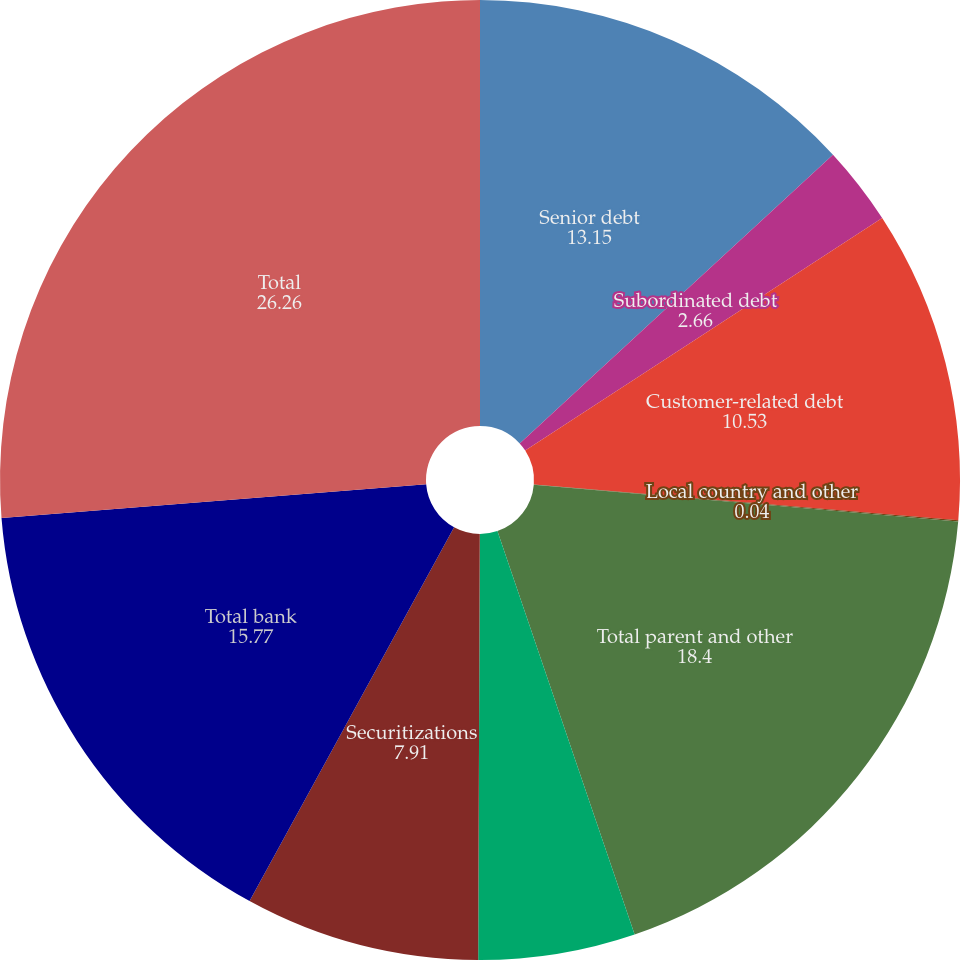Convert chart. <chart><loc_0><loc_0><loc_500><loc_500><pie_chart><fcel>Senior debt<fcel>Subordinated debt<fcel>Customer-related debt<fcel>Local country and other<fcel>Total parent and other<fcel>FHLB borrowings<fcel>Securitizations<fcel>Total bank<fcel>Total<nl><fcel>13.15%<fcel>2.66%<fcel>10.53%<fcel>0.04%<fcel>18.4%<fcel>5.28%<fcel>7.91%<fcel>15.77%<fcel>26.26%<nl></chart> 